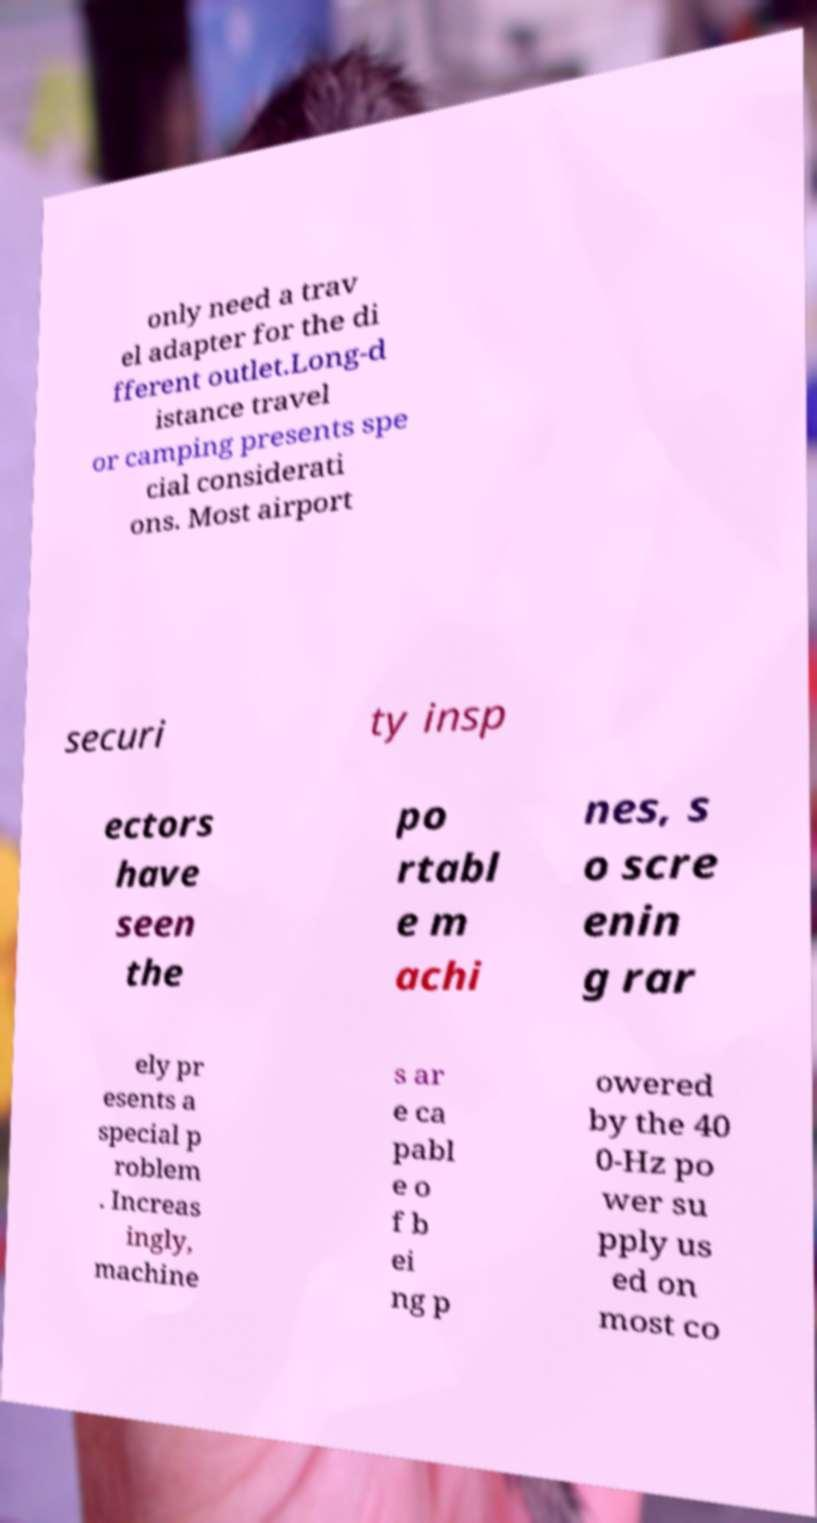There's text embedded in this image that I need extracted. Can you transcribe it verbatim? only need a trav el adapter for the di fferent outlet.Long-d istance travel or camping presents spe cial considerati ons. Most airport securi ty insp ectors have seen the po rtabl e m achi nes, s o scre enin g rar ely pr esents a special p roblem . Increas ingly, machine s ar e ca pabl e o f b ei ng p owered by the 40 0-Hz po wer su pply us ed on most co 